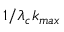<formula> <loc_0><loc_0><loc_500><loc_500>1 / \lambda _ { c } k _ { \max }</formula> 